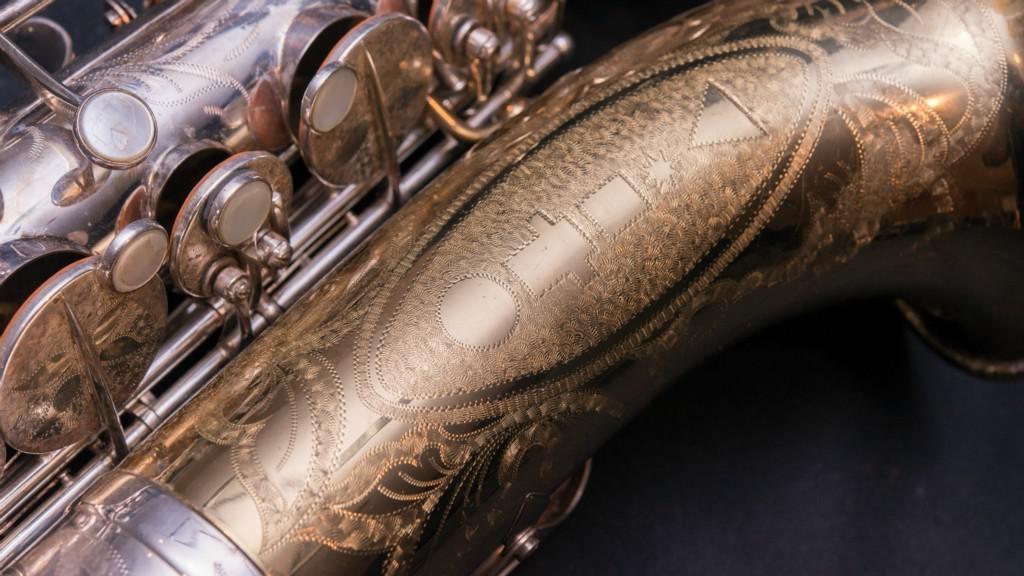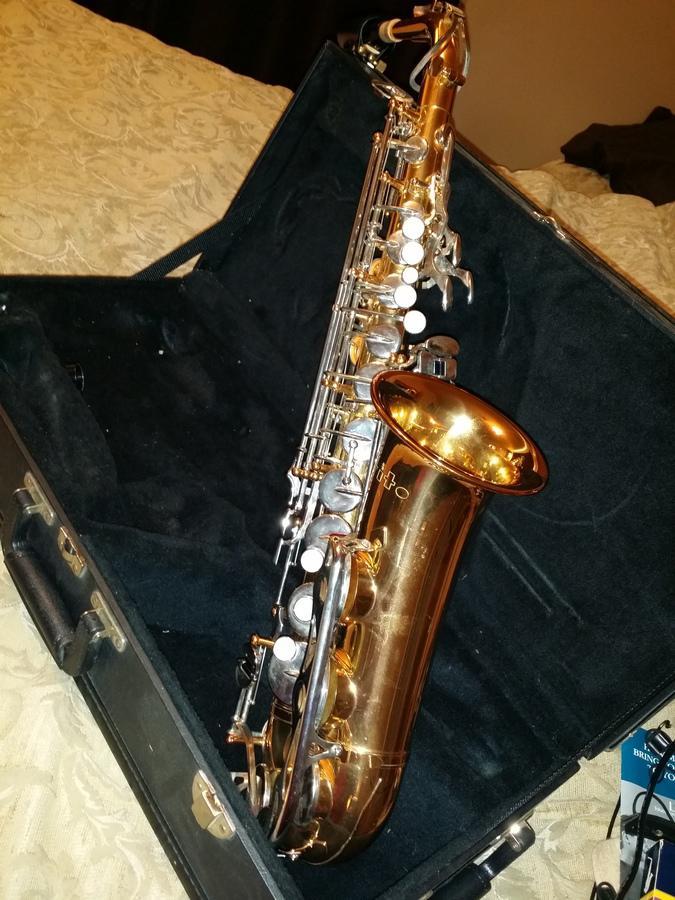The first image is the image on the left, the second image is the image on the right. For the images shown, is this caption "Both images contain an engraving on the saxophone that designates where the saxophone was made." true? Answer yes or no. No. The first image is the image on the left, the second image is the image on the right. For the images shown, is this caption "One image includes the upturned shiny gold bell of at least one saxophone, and the other image shows the etched surface of a saxophone that is more copper colored." true? Answer yes or no. Yes. 